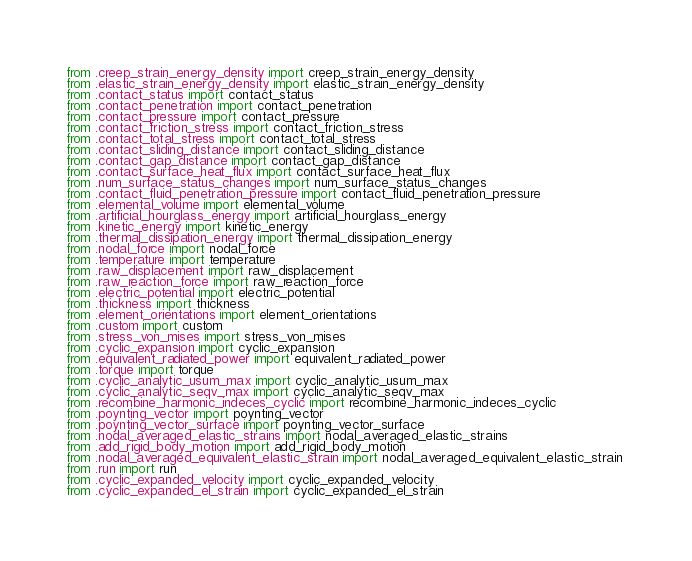Convert code to text. <code><loc_0><loc_0><loc_500><loc_500><_Python_>from .creep_strain_energy_density import creep_strain_energy_density 
from .elastic_strain_energy_density import elastic_strain_energy_density 
from .contact_status import contact_status 
from .contact_penetration import contact_penetration 
from .contact_pressure import contact_pressure 
from .contact_friction_stress import contact_friction_stress 
from .contact_total_stress import contact_total_stress 
from .contact_sliding_distance import contact_sliding_distance 
from .contact_gap_distance import contact_gap_distance 
from .contact_surface_heat_flux import contact_surface_heat_flux 
from .num_surface_status_changes import num_surface_status_changes 
from .contact_fluid_penetration_pressure import contact_fluid_penetration_pressure 
from .elemental_volume import elemental_volume 
from .artificial_hourglass_energy import artificial_hourglass_energy 
from .kinetic_energy import kinetic_energy 
from .thermal_dissipation_energy import thermal_dissipation_energy 
from .nodal_force import nodal_force 
from .temperature import temperature 
from .raw_displacement import raw_displacement 
from .raw_reaction_force import raw_reaction_force 
from .electric_potential import electric_potential 
from .thickness import thickness 
from .element_orientations import element_orientations 
from .custom import custom 
from .stress_von_mises import stress_von_mises 
from .cyclic_expansion import cyclic_expansion 
from .equivalent_radiated_power import equivalent_radiated_power 
from .torque import torque 
from .cyclic_analytic_usum_max import cyclic_analytic_usum_max 
from .cyclic_analytic_seqv_max import cyclic_analytic_seqv_max 
from .recombine_harmonic_indeces_cyclic import recombine_harmonic_indeces_cyclic 
from .poynting_vector import poynting_vector 
from .poynting_vector_surface import poynting_vector_surface 
from .nodal_averaged_elastic_strains import nodal_averaged_elastic_strains 
from .add_rigid_body_motion import add_rigid_body_motion 
from .nodal_averaged_equivalent_elastic_strain import nodal_averaged_equivalent_elastic_strain 
from .run import run 
from .cyclic_expanded_velocity import cyclic_expanded_velocity 
from .cyclic_expanded_el_strain import cyclic_expanded_el_strain </code> 